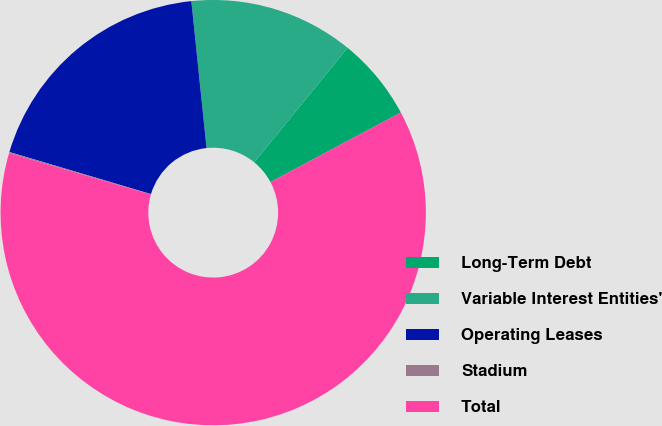<chart> <loc_0><loc_0><loc_500><loc_500><pie_chart><fcel>Long-Term Debt<fcel>Variable Interest Entities'<fcel>Operating Leases<fcel>Stadium<fcel>Total<nl><fcel>6.31%<fcel>12.53%<fcel>18.76%<fcel>0.09%<fcel>62.32%<nl></chart> 